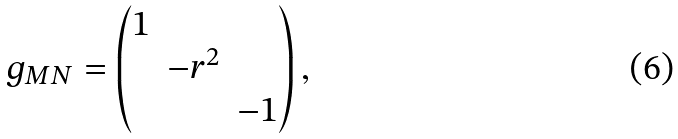Convert formula to latex. <formula><loc_0><loc_0><loc_500><loc_500>g _ { M N } = \begin{pmatrix} 1 & & \\ & - r ^ { 2 } & \\ & & - 1 \end{pmatrix} ,</formula> 